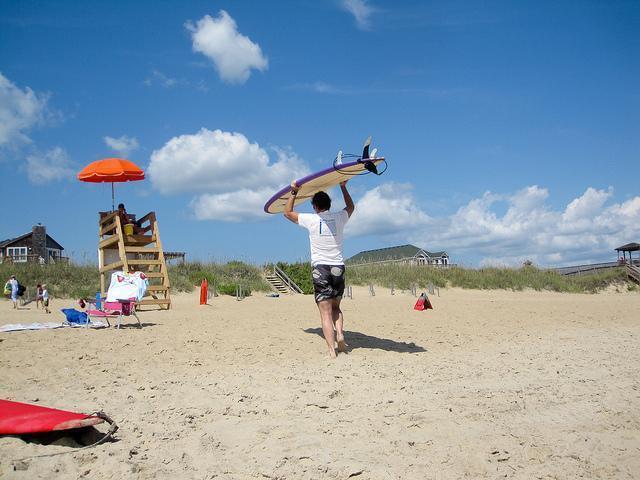How many surfboards can you see?
Give a very brief answer. 2. How many chairs can be seen?
Give a very brief answer. 2. 